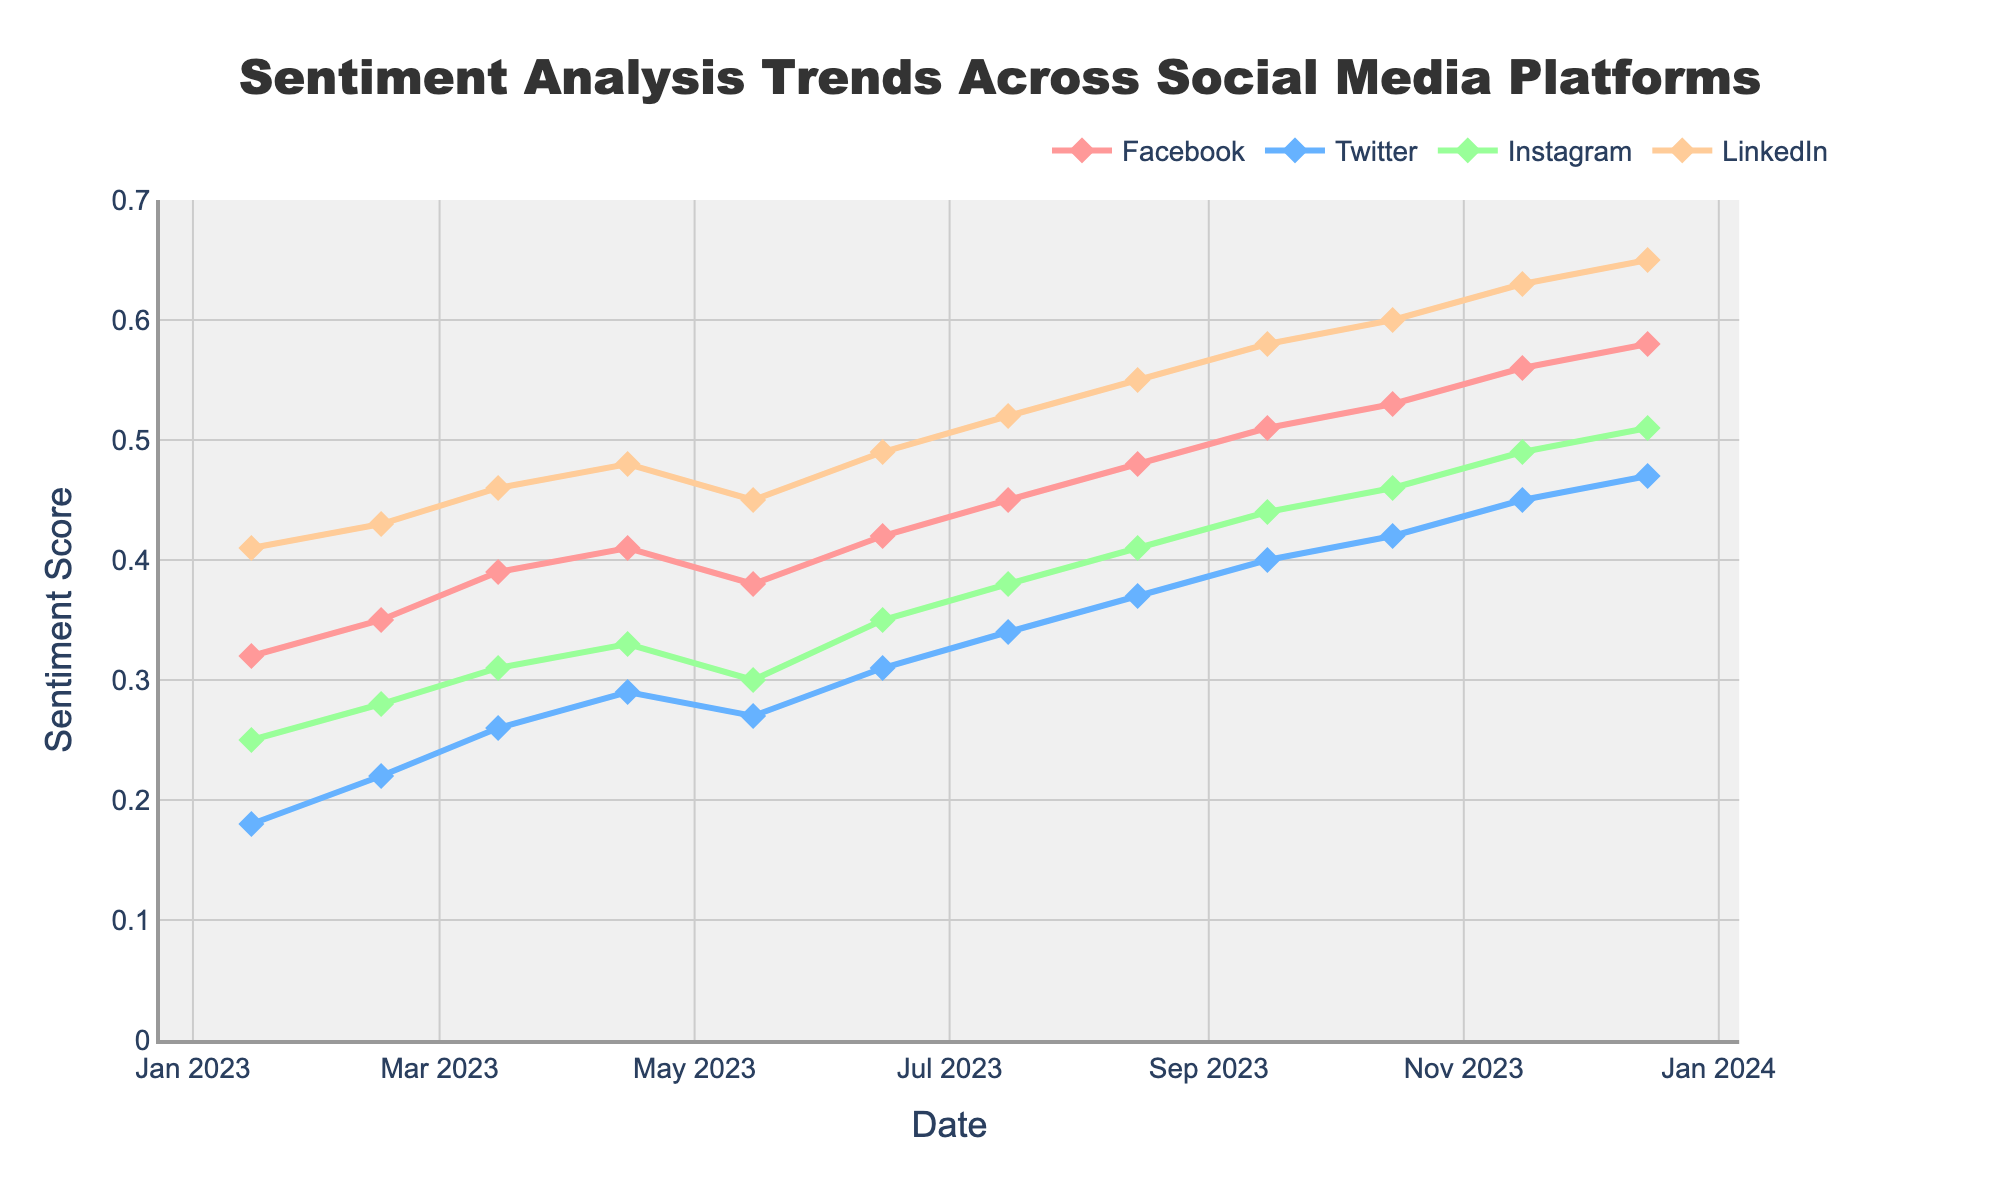Which social media platform has the highest sentiment score in December 2023? By looking at the sentiment scores for December 2023, LinkedIn has the highest sentiment score with a value of 0.65.
Answer: LinkedIn How did the sentiment score of Instagram change from January 2023 to December 2023? The sentiment score for Instagram in January 2023 was 0.25. In December 2023, it rose to 0.51. The change is 0.51 - 0.25, which equals an increase of 0.26.
Answer: Increased by 0.26 Which platform showed the most improvement in sentiment score from the start to the end of the period? By comparing the improvements from January to December 2023: Facebook increased from 0.32 to 0.58 (0.26), Twitter from 0.18 to 0.47 (0.29), Instagram from 0.25 to 0.51 (0.26), and LinkedIn from 0.41 to 0.65 (0.24). Therefore, Twitter showed the most improvement with an increase of 0.29.
Answer: Twitter On average, how often do sentiment scores increase across all platforms? To find the average frequency of increases, observe each platform's trends. From the data, monthly increases are noted for Facebook (11 times), Twitter (11 times), Instagram (10 times), and LinkedIn (11 times). Adding them up gives 43 increases over 12 months, averaging approximately 3.58 increases per month.
Answer: 3.58 times per month Which month had the smallest sentiment score for Instagram? From the data, Instagram had the smallest sentiment score in January 2023 at 0.25.
Answer: January 2023 What is the range of sentiment scores for LinkedIn throughout the year? The lowest sentiment score for LinkedIn is 0.41 in January 2023, and the highest is 0.65 in December 2023. The range is calculated as 0.65 - 0.41, which equals 0.24.
Answer: 0.24 Between Facebook and Twitter, whose sentiment score had a higher increase in October 2023 compared to September 2023? In September 2023, Facebook had a score of 0.51, and in October 2023, it increased to 0.53 (0.02 increase). Twitter’s score went from 0.40 in September to 0.42 in October, also a 0.02 increase. Therefore, both platforms had the same increase in October 2023.
Answer: Both had the same increase What is the average sentiment score for Twitter across all months in 2023? Summing up all the sentiment scores for Twitter (0.18, 0.22, 0.26, 0.29, 0.27, 0.31, 0.34, 0.37, 0.40, 0.42, 0.45, 0.47) and dividing by 12: (0.18 + 0.22 + 0.26 + 0.29 + 0.27 + 0.31 + 0.34 + 0.37 + 0.40 + 0.42 + 0.45 + 0.47) / 12 = 0.34417.
Answer: 0.344 Visually, which platform has the green-colored line? Observing the visual attributes of the chart, Instagram is associated with the green-colored line.
Answer: Instagram 